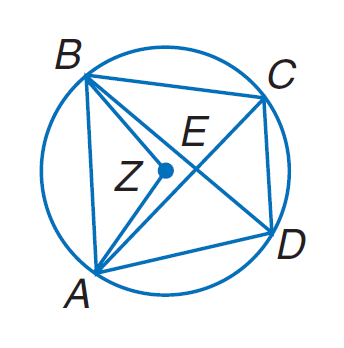Answer the mathemtical geometry problem and directly provide the correct option letter.
Question: Quadrilateral A B C D is inscribed in \odot Z such that m \angle B Z A = 104, m \widehat C B = 94, and A B \parallel D C. Find m \angle B D A.
Choices: A: 36 B: 52 C: 94 D: 104 B 